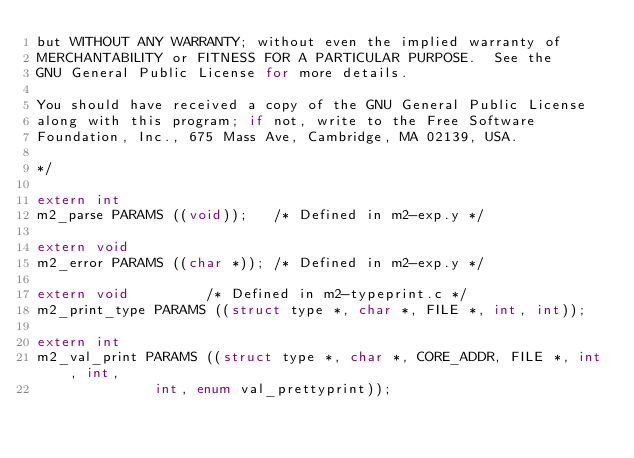<code> <loc_0><loc_0><loc_500><loc_500><_C_>but WITHOUT ANY WARRANTY; without even the implied warranty of
MERCHANTABILITY or FITNESS FOR A PARTICULAR PURPOSE.  See the
GNU General Public License for more details.

You should have received a copy of the GNU General Public License
along with this program; if not, write to the Free Software
Foundation, Inc., 675 Mass Ave, Cambridge, MA 02139, USA.

*/

extern int
m2_parse PARAMS ((void));	/* Defined in m2-exp.y */

extern void
m2_error PARAMS ((char *));	/* Defined in m2-exp.y */

extern void			/* Defined in m2-typeprint.c */
m2_print_type PARAMS ((struct type *, char *, FILE *, int, int));

extern int
m2_val_print PARAMS ((struct type *, char *, CORE_ADDR, FILE *, int, int,
		      int, enum val_prettyprint));
</code> 